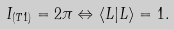Convert formula to latex. <formula><loc_0><loc_0><loc_500><loc_500>I _ { ( T 1 ) } = 2 \pi \Leftrightarrow \langle L | L \rangle = 1 .</formula> 